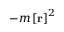<formula> <loc_0><loc_0><loc_500><loc_500>- m \left [ r \right ] ^ { 2 }</formula> 